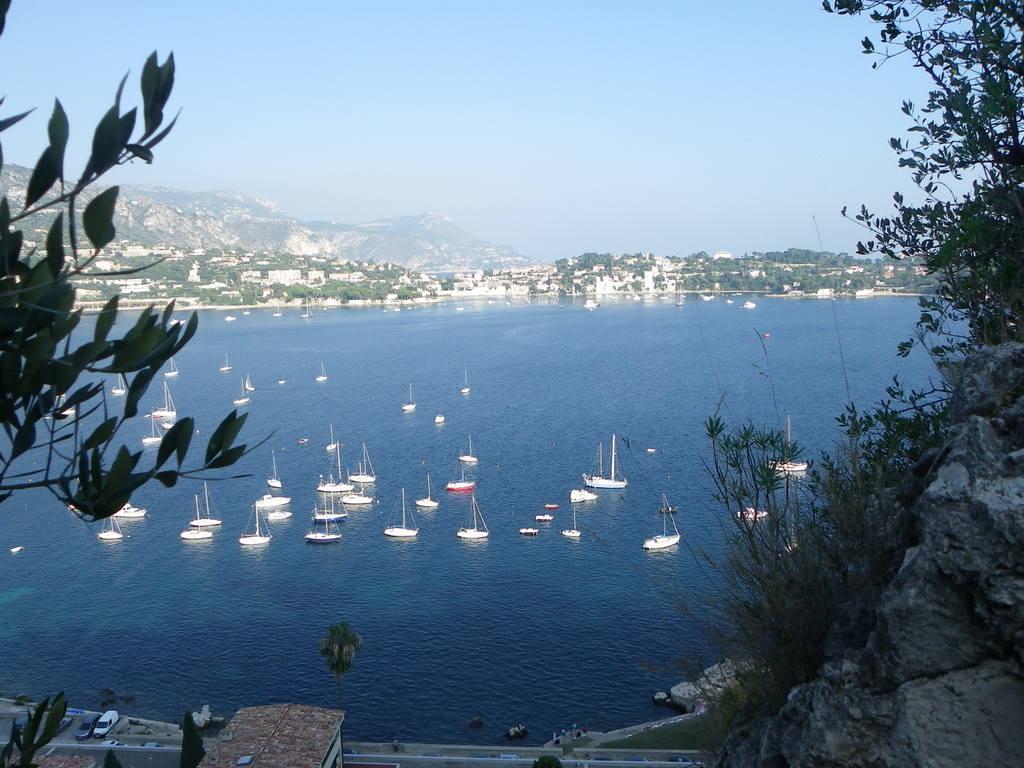In one or two sentences, can you explain what this image depicts? In this image we can see a group of boats on the water. Behind the water we can see a group of trees, buildings and mountains. At the top we can see the sky. On the left side, we can see leaves. On the right side, we can see a rock and a few plants. At the bottom we can see few vehicles, trees and grass. 